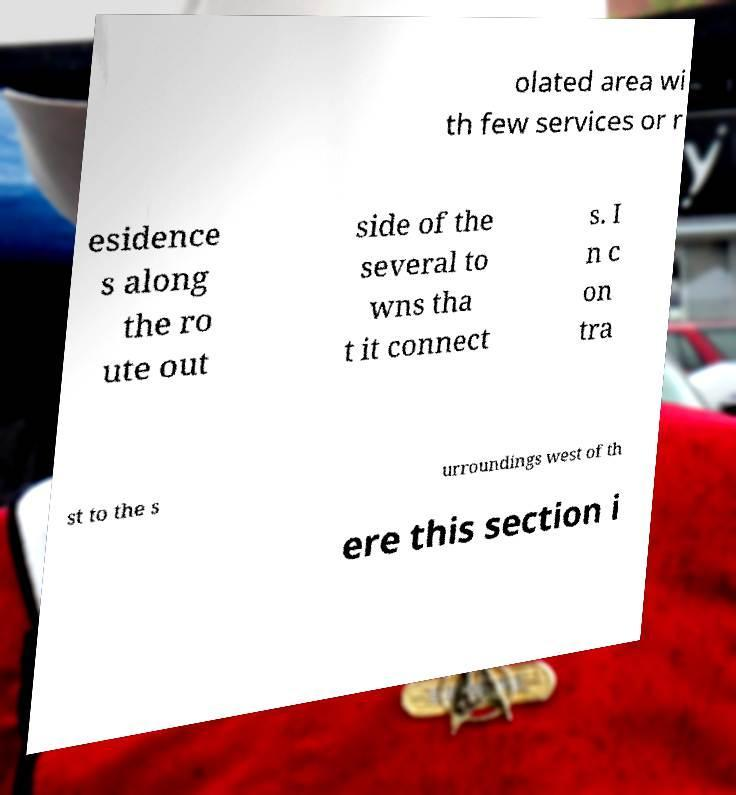Can you accurately transcribe the text from the provided image for me? olated area wi th few services or r esidence s along the ro ute out side of the several to wns tha t it connect s. I n c on tra st to the s urroundings west of th ere this section i 